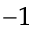Convert formula to latex. <formula><loc_0><loc_0><loc_500><loc_500>^ { - 1 }</formula> 